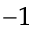Convert formula to latex. <formula><loc_0><loc_0><loc_500><loc_500>^ { - 1 }</formula> 